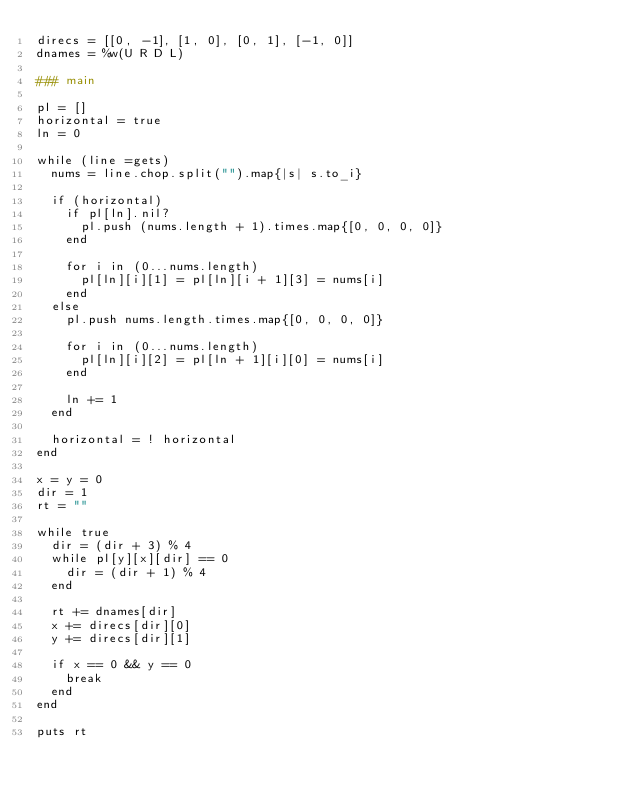Convert code to text. <code><loc_0><loc_0><loc_500><loc_500><_Ruby_>direcs = [[0, -1], [1, 0], [0, 1], [-1, 0]]
dnames = %w(U R D L)

### main

pl = []
horizontal = true
ln = 0

while (line =gets)
  nums = line.chop.split("").map{|s| s.to_i}

  if (horizontal)
    if pl[ln].nil?
      pl.push (nums.length + 1).times.map{[0, 0, 0, 0]}
    end

    for i in (0...nums.length)
      pl[ln][i][1] = pl[ln][i + 1][3] = nums[i]
    end
  else
    pl.push nums.length.times.map{[0, 0, 0, 0]}

    for i in (0...nums.length)
      pl[ln][i][2] = pl[ln + 1][i][0] = nums[i]
    end

    ln += 1
  end

  horizontal = ! horizontal
end

x = y = 0
dir = 1
rt = ""

while true
  dir = (dir + 3) % 4
  while pl[y][x][dir] == 0
    dir = (dir + 1) % 4
  end

  rt += dnames[dir]
  x += direcs[dir][0]
  y += direcs[dir][1]

  if x == 0 && y == 0
    break
  end
end

puts rt</code> 